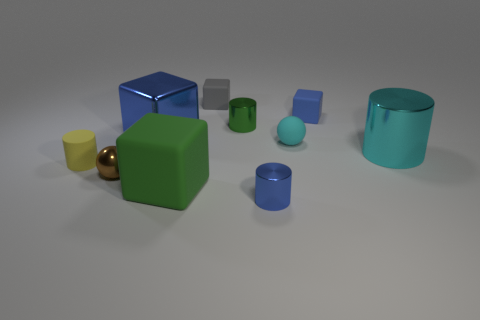There is a matte block on the right side of the green thing right of the green rubber thing; how big is it?
Provide a succinct answer. Small. What is the cylinder behind the big cyan metal thing made of?
Ensure brevity in your answer.  Metal. How many objects are large cubes that are in front of the tiny brown metal thing or objects in front of the tiny yellow matte thing?
Make the answer very short. 3. What material is the small green object that is the same shape as the yellow object?
Make the answer very short. Metal. Is the color of the big metal thing on the left side of the small blue metallic cylinder the same as the object in front of the large matte object?
Provide a succinct answer. Yes. Is there a green metallic sphere of the same size as the blue metal block?
Your response must be concise. No. There is a object that is behind the tiny matte ball and on the left side of the tiny gray block; what is its material?
Keep it short and to the point. Metal. What number of metallic things are either yellow spheres or tiny yellow cylinders?
Keep it short and to the point. 0. The big green object that is made of the same material as the gray cube is what shape?
Offer a very short reply. Cube. What number of objects are in front of the tiny matte cylinder and behind the blue cylinder?
Provide a short and direct response. 2. 